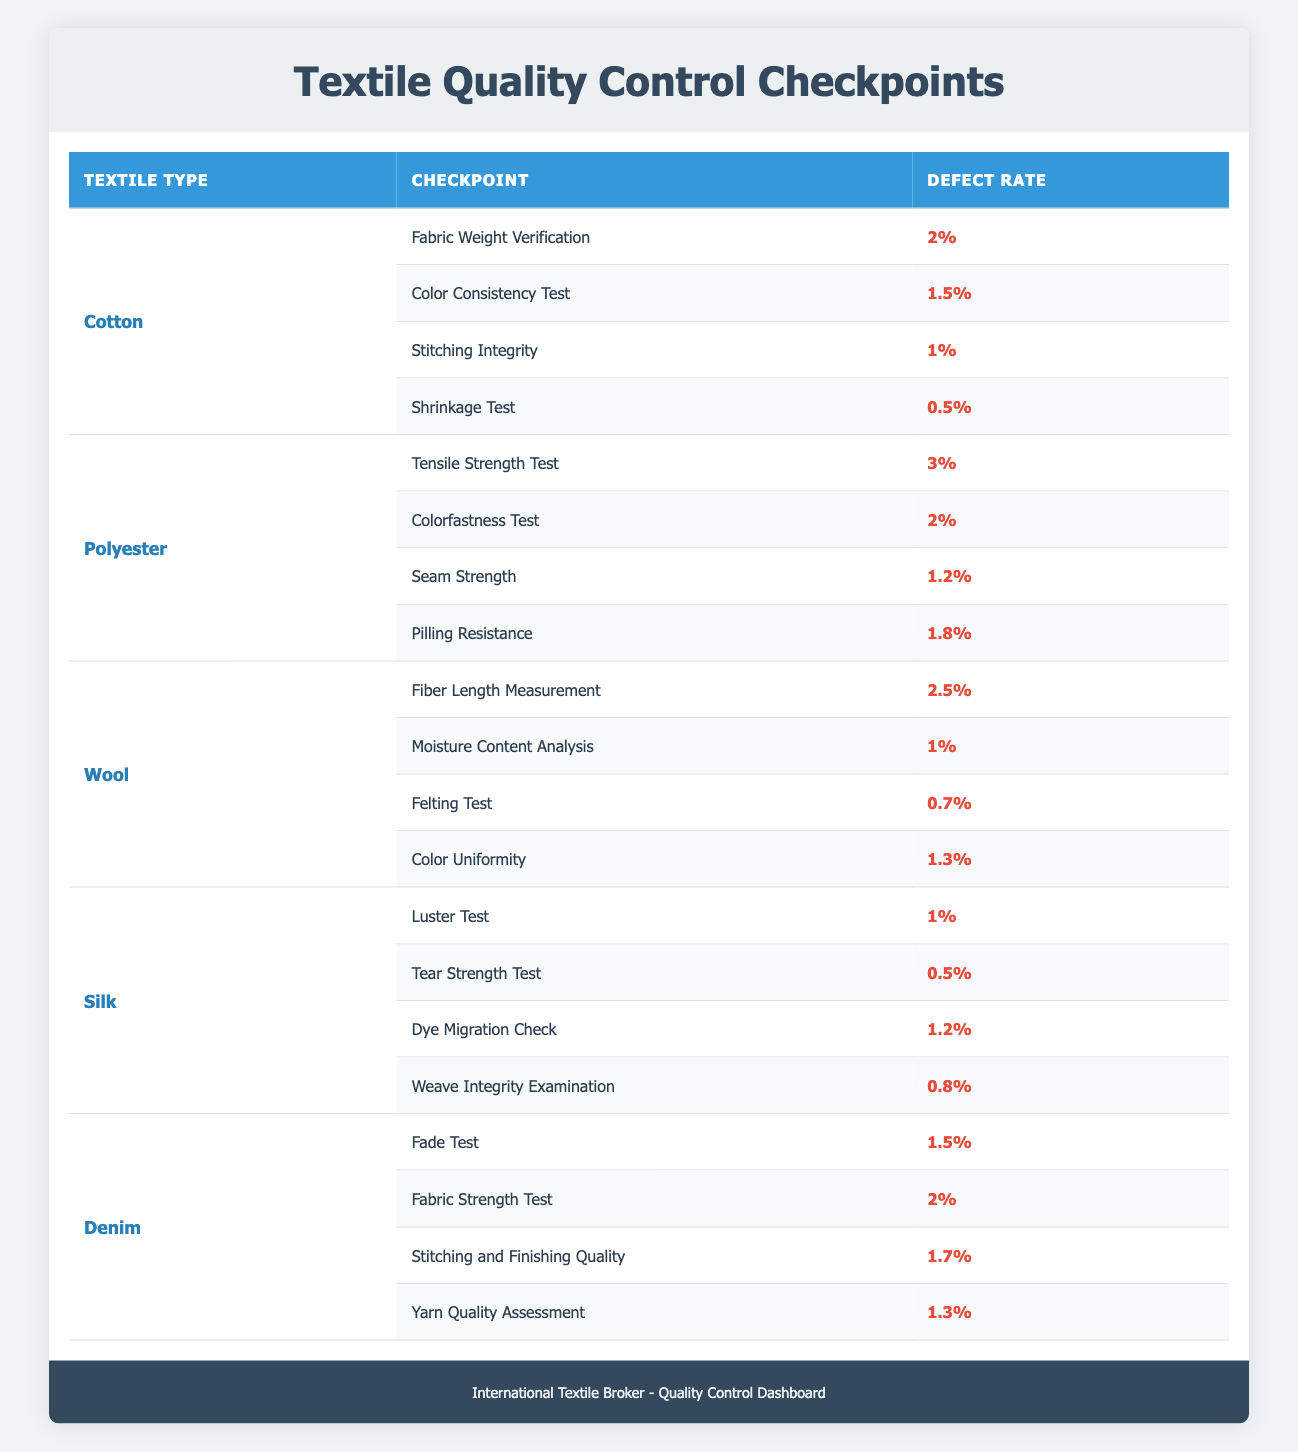What is the defect rate for the "Fabric Weight Verification" checkpoint in cotton? The table lists the defect rates for various checkpoints under different textile types. For cotton, the "Fabric Weight Verification" checkpoint shows a defect rate of 2%.
Answer: 2% Which textile type has the highest defect rate in its quality control checkpoints? By examining the defect rates for all textile types, polyester has the highest defect rate at the "Tensile Strength Test," which is 3%.
Answer: Polyester What is the average defect rate for silk quality control checkpoints? To find the average defect rate for silk, we sum the defect rates: (1% + 0.5% + 1.2% + 0.8%) = 3.5%. There are four checkpoints, so the average is 3.5% / 4 = 0.875%.
Answer: 0.875% Is the defect rate for "Stitching Integrity" in cotton lower than the defect rate for "Seam Strength" in polyester? The defect rate for "Stitching Integrity" in cotton is 1%, while the defect rate for "Seam Strength" in polyester is 1.2%. Since 1% is lower than 1.2%, the statement is true.
Answer: Yes What are the defect rates for the "Fade Test" and the "Fabric Strength Test" for denim? The defect rate for the "Fade Test" in denim is 1.5%, and for the "Fabric Strength Test," it is 2%. We can see these rates directly listed in the table under denim's checkpoints.
Answer: 1.5% and 2% Which textile type has the lowest defect rate for any of its checkpoints and what is that rate? By scanning through the defect rates for all textile types, the lowest defect rate found is 0.5% for both the "Shrinkage Test" in cotton and the "Tear Strength Test" in silk. Identifying the minimum defect rate requires checking all rates in the table.
Answer: 0.5% Is there a checkpoint with a defect rate of over 2% in wool? The highest defect rate for wool is found in "Fiber Length Measurement" at 2.5%. Since this rate is over 2%, the statement is true.
Answer: Yes What is the total defect rate for all checkpoints of polyester? To get the total defect rate for polyester, we add the defect rates: 3% + 2% + 1.2% + 1.8% = 8%. This requires looking at all the checkpoints specific to polyester.
Answer: 8% 